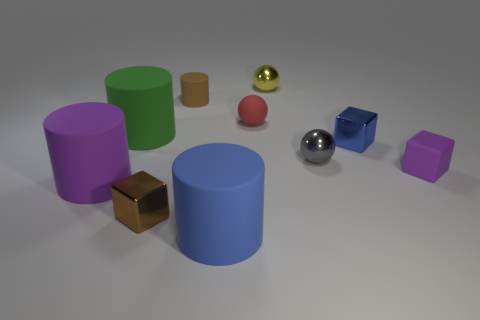Subtract all small yellow metal balls. How many balls are left? 2 Subtract all brown blocks. How many blocks are left? 2 Subtract 1 cubes. How many cubes are left? 2 Subtract all cylinders. How many objects are left? 6 Subtract all tiny brown rubber objects. Subtract all big green matte cylinders. How many objects are left? 8 Add 5 blue metal cubes. How many blue metal cubes are left? 6 Add 7 gray metallic objects. How many gray metallic objects exist? 8 Subtract 1 green cylinders. How many objects are left? 9 Subtract all red cubes. Subtract all purple spheres. How many cubes are left? 3 Subtract all cyan cubes. How many red cylinders are left? 0 